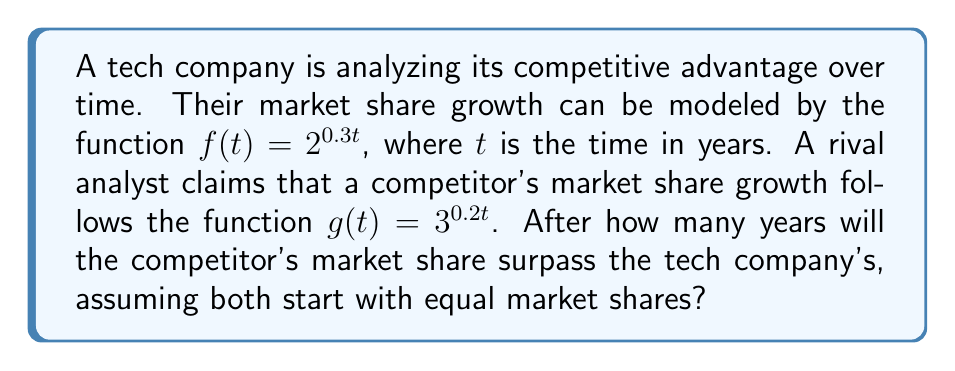Show me your answer to this math problem. To solve this problem, we need to find the time $t$ when $g(t) > f(t)$:

1) Set up the inequality:
   $3^{0.2t} > 2^{0.3t}$

2) Take the natural logarithm of both sides:
   $\ln(3^{0.2t}) > \ln(2^{0.3t})$

3) Using the logarithm property $\ln(a^b) = b\ln(a)$:
   $0.2t \ln(3) > 0.3t \ln(2)$

4) Subtract $0.3t \ln(2)$ from both sides:
   $0.2t \ln(3) - 0.3t \ln(2) > 0$

5) Factor out $t$:
   $t(0.2 \ln(3) - 0.3 \ln(2)) > 0$

6) Divide both sides by the coefficient of $t$:
   $t > \frac{0}{0.2 \ln(3) - 0.3 \ln(2)}$

7) Simplify:
   $t > \frac{0}{0.2 \ln(3) - 0.3 \ln(2)} \approx 11.0933$

8) Since time must be a whole number of years, we round up to the next integer.
Answer: The competitor's market share will surpass the tech company's after 12 years. 